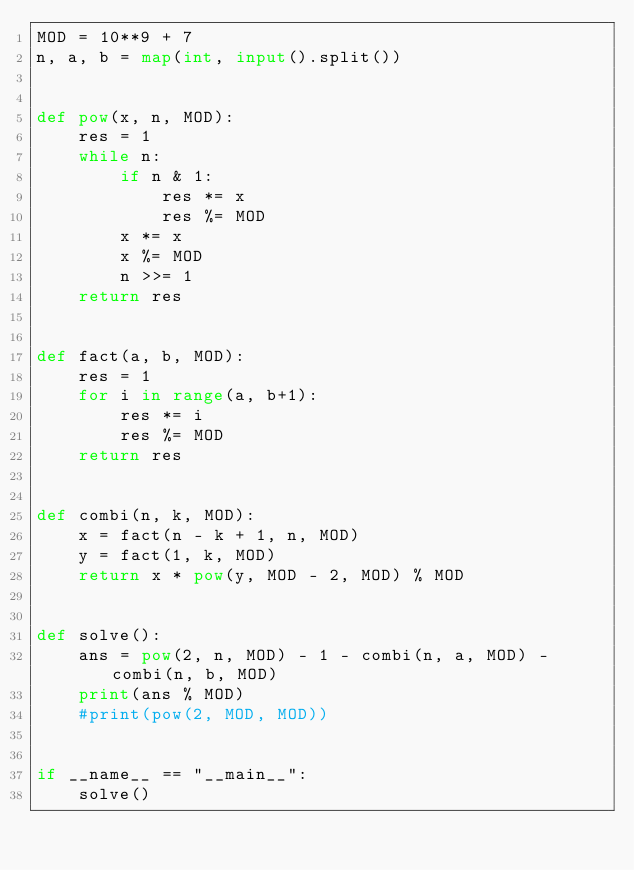<code> <loc_0><loc_0><loc_500><loc_500><_Python_>MOD = 10**9 + 7
n, a, b = map(int, input().split())


def pow(x, n, MOD):
    res = 1
    while n:
        if n & 1:
            res *= x
            res %= MOD
        x *= x
        x %= MOD
        n >>= 1
    return res    


def fact(a, b, MOD):
    res = 1
    for i in range(a, b+1):
        res *= i
        res %= MOD
    return res


def combi(n, k, MOD):
    x = fact(n - k + 1, n, MOD)
    y = fact(1, k, MOD)
    return x * pow(y, MOD - 2, MOD) % MOD
    

def solve():
    ans = pow(2, n, MOD) - 1 - combi(n, a, MOD) - combi(n, b, MOD)
    print(ans % MOD)
    #print(pow(2, MOD, MOD))


if __name__ == "__main__":
    solve()</code> 